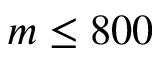<formula> <loc_0><loc_0><loc_500><loc_500>m \leq 8 0 0</formula> 